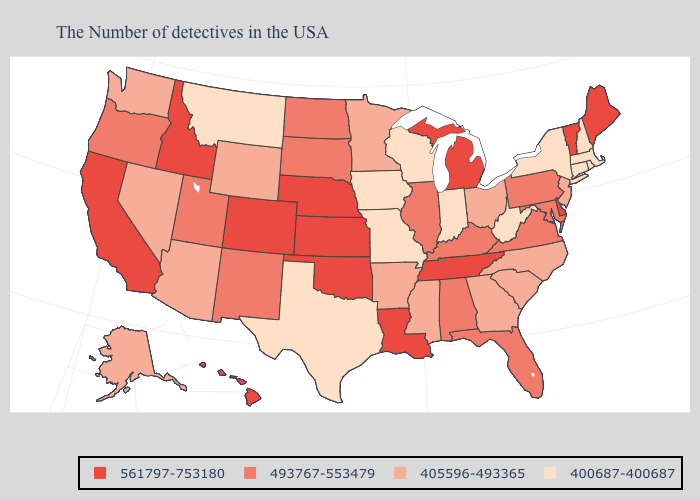What is the lowest value in states that border New York?
Give a very brief answer. 400687-400687. Name the states that have a value in the range 405596-493365?
Keep it brief. New Jersey, North Carolina, South Carolina, Ohio, Georgia, Mississippi, Arkansas, Minnesota, Wyoming, Arizona, Nevada, Washington, Alaska. Does the first symbol in the legend represent the smallest category?
Quick response, please. No. Name the states that have a value in the range 561797-753180?
Be succinct. Maine, Vermont, Delaware, Michigan, Tennessee, Louisiana, Kansas, Nebraska, Oklahoma, Colorado, Idaho, California, Hawaii. Among the states that border Ohio , which have the lowest value?
Write a very short answer. West Virginia, Indiana. Among the states that border Michigan , which have the highest value?
Give a very brief answer. Ohio. What is the lowest value in the USA?
Quick response, please. 400687-400687. What is the highest value in the USA?
Answer briefly. 561797-753180. Does Missouri have the lowest value in the USA?
Answer briefly. Yes. What is the highest value in the USA?
Be succinct. 561797-753180. Is the legend a continuous bar?
Give a very brief answer. No. What is the highest value in the USA?
Short answer required. 561797-753180. What is the value of Colorado?
Concise answer only. 561797-753180. What is the value of Wisconsin?
Be succinct. 400687-400687. Name the states that have a value in the range 405596-493365?
Be succinct. New Jersey, North Carolina, South Carolina, Ohio, Georgia, Mississippi, Arkansas, Minnesota, Wyoming, Arizona, Nevada, Washington, Alaska. 